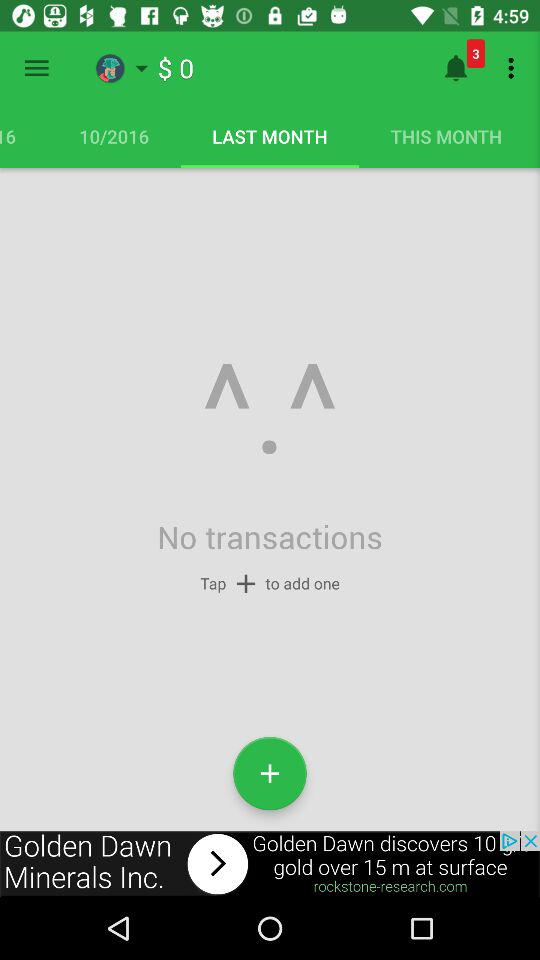How much is the total cost of last month's transactions?
When the provided information is insufficient, respond with <no answer>. <no answer> 